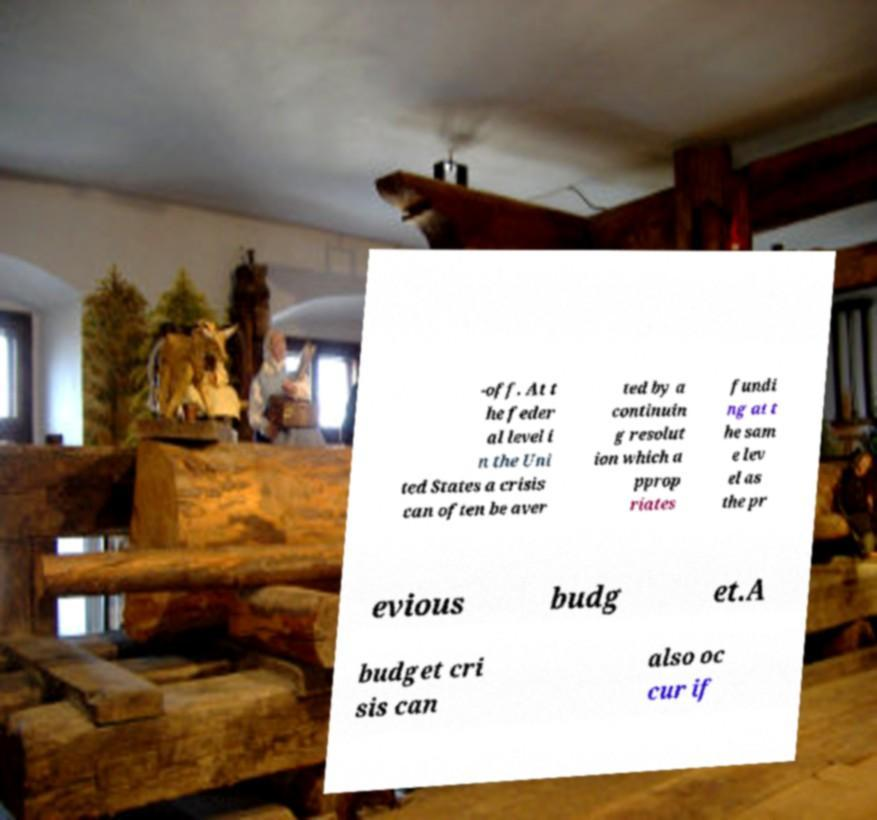What messages or text are displayed in this image? I need them in a readable, typed format. -off. At t he feder al level i n the Uni ted States a crisis can often be aver ted by a continuin g resolut ion which a pprop riates fundi ng at t he sam e lev el as the pr evious budg et.A budget cri sis can also oc cur if 